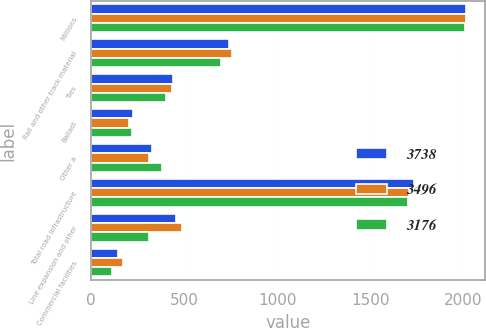Convert chart to OTSL. <chart><loc_0><loc_0><loc_500><loc_500><stacked_bar_chart><ecel><fcel>Millions<fcel>Rail and other track material<fcel>Ties<fcel>Ballast<fcel>Other a<fcel>Total road infrastructure<fcel>Line expansion and other<fcel>Commercial facilities<nl><fcel>3738<fcel>2013<fcel>743<fcel>438<fcel>226<fcel>326<fcel>1733<fcel>455<fcel>146<nl><fcel>3496<fcel>2012<fcel>759<fcel>434<fcel>203<fcel>312<fcel>1708<fcel>489<fcel>169<nl><fcel>3176<fcel>2011<fcel>697<fcel>403<fcel>220<fcel>382<fcel>1702<fcel>311<fcel>111<nl></chart> 